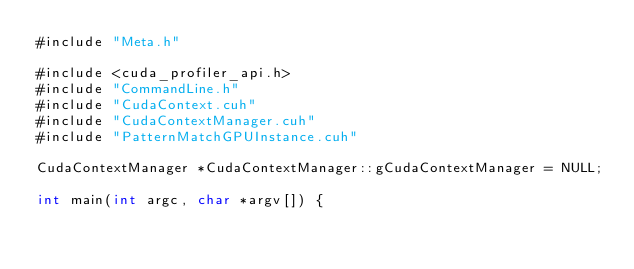Convert code to text. <code><loc_0><loc_0><loc_500><loc_500><_Cuda_>#include "Meta.h"

#include <cuda_profiler_api.h>
#include "CommandLine.h"
#include "CudaContext.cuh"
#include "CudaContextManager.cuh"
#include "PatternMatchGPUInstance.cuh"

CudaContextManager *CudaContextManager::gCudaContextManager = NULL;

int main(int argc, char *argv[]) {</code> 